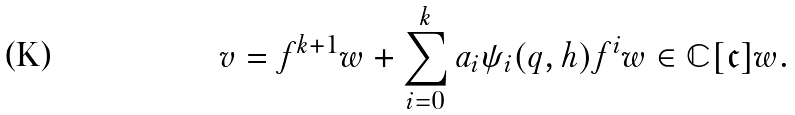Convert formula to latex. <formula><loc_0><loc_0><loc_500><loc_500>v & = f ^ { k + 1 } w + \sum _ { i = 0 } ^ { k } a _ { i } \psi _ { i } ( q , h ) f ^ { i } w \in \mathbb { C } [ \mathfrak { c } ] w .</formula> 